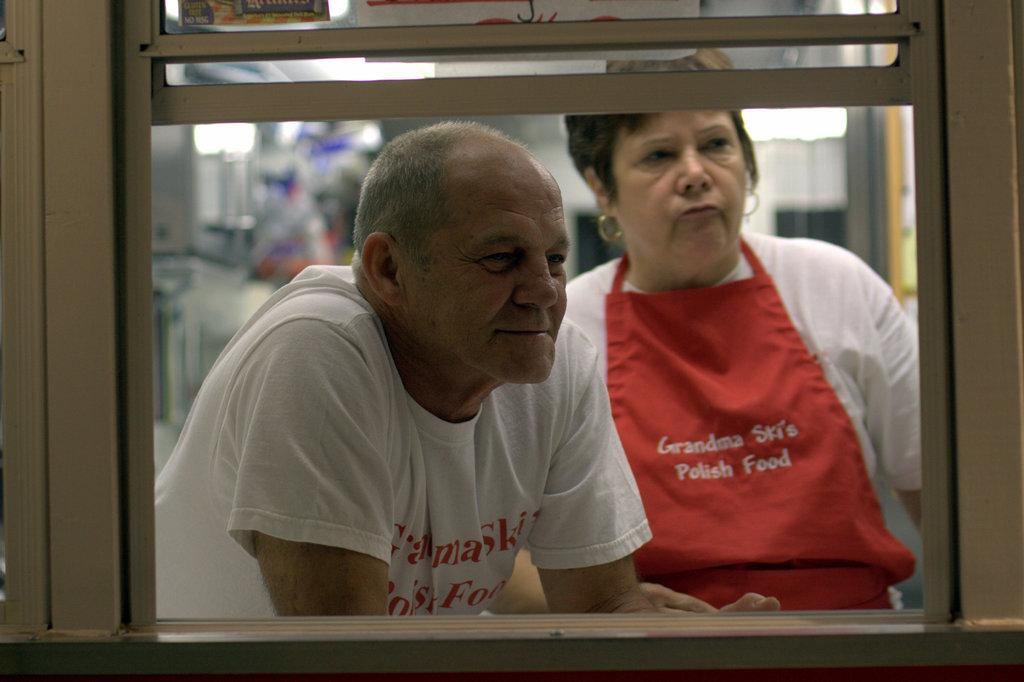How many people are in the image? There are two people in the image. What are the people wearing? Both people are wearing white t-shirts. Can you describe the background of the image? The background of the image is blurred. How many houses can be seen in the image? There are no houses visible in the image. Can you describe the kick performed by one of the people in the image? There is no kick being performed by either person in the image. 